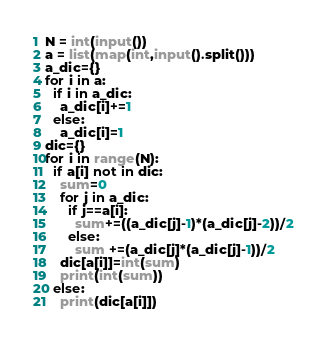<code> <loc_0><loc_0><loc_500><loc_500><_Python_>N = int(input())
a = list(map(int,input().split()))
a_dic={}
for i in a:
  if i in a_dic:
    a_dic[i]+=1
  else:
    a_dic[i]=1
dic={}
for i in range(N):
  if a[i] not in dic:
    sum=0
    for j in a_dic:
      if j==a[i]:
        sum+=((a_dic[j]-1)*(a_dic[j]-2))/2
      else:
        sum +=(a_dic[j]*(a_dic[j]-1))/2
    dic[a[i]]=int(sum)
    print(int(sum))
  else:
    print(dic[a[i]])
</code> 